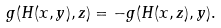Convert formula to latex. <formula><loc_0><loc_0><loc_500><loc_500>g ( H ( x , y ) , z ) = - g ( H ( x , z ) , y ) .</formula> 